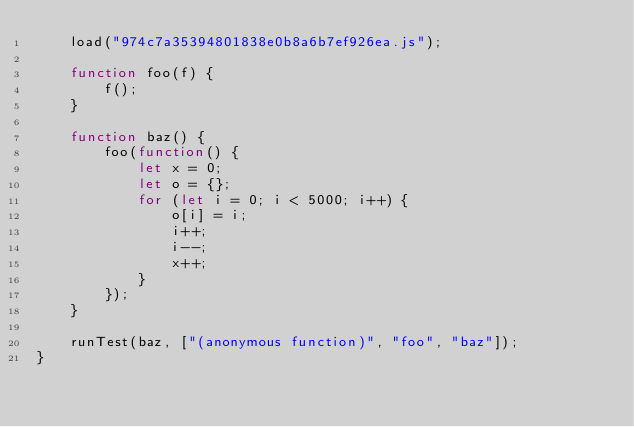<code> <loc_0><loc_0><loc_500><loc_500><_JavaScript_>    load("974c7a35394801838e0b8a6b7ef926ea.js");

    function foo(f) {
        f();
    }

    function baz() {
        foo(function() {
            let x = 0;
            let o = {};
            for (let i = 0; i < 5000; i++) {
                o[i] = i;
                i++;
                i--;
                x++;
            }
        });
    }

    runTest(baz, ["(anonymous function)", "foo", "baz"]);
}
</code> 